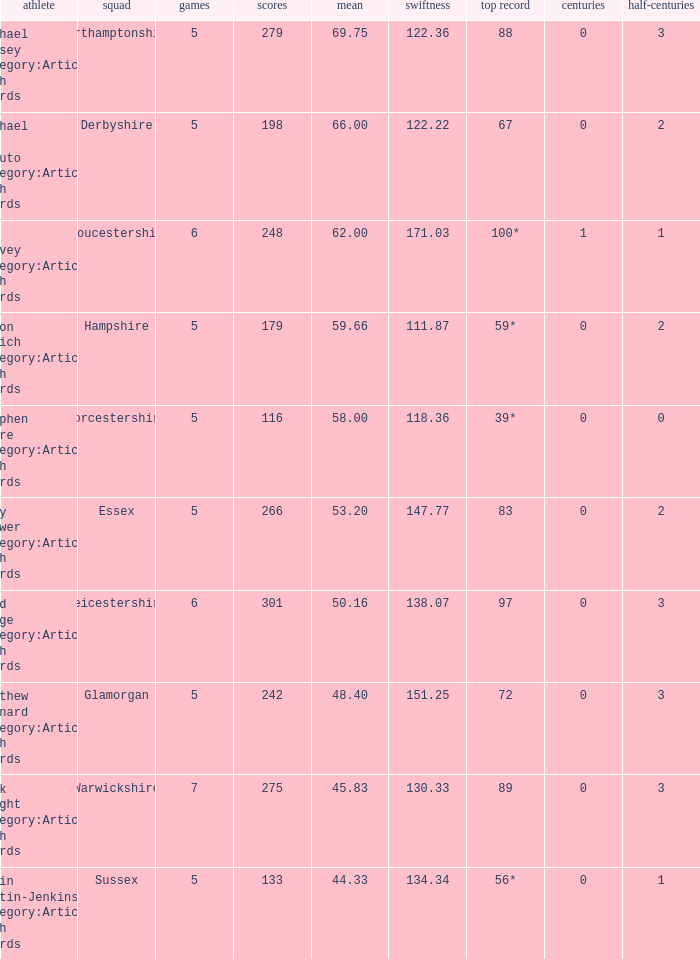What is the smallest amount of matches? 5.0. 